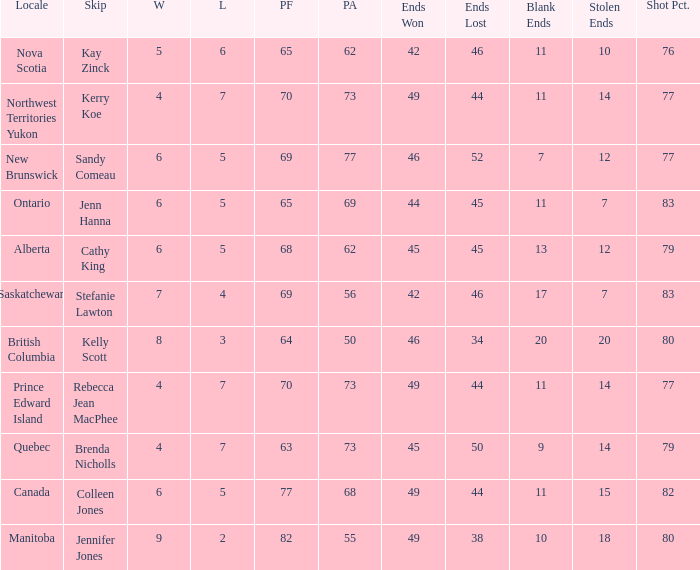Help me parse the entirety of this table. {'header': ['Locale', 'Skip', 'W', 'L', 'PF', 'PA', 'Ends Won', 'Ends Lost', 'Blank Ends', 'Stolen Ends', 'Shot Pct.'], 'rows': [['Nova Scotia', 'Kay Zinck', '5', '6', '65', '62', '42', '46', '11', '10', '76'], ['Northwest Territories Yukon', 'Kerry Koe', '4', '7', '70', '73', '49', '44', '11', '14', '77'], ['New Brunswick', 'Sandy Comeau', '6', '5', '69', '77', '46', '52', '7', '12', '77'], ['Ontario', 'Jenn Hanna', '6', '5', '65', '69', '44', '45', '11', '7', '83'], ['Alberta', 'Cathy King', '6', '5', '68', '62', '45', '45', '13', '12', '79'], ['Saskatchewan', 'Stefanie Lawton', '7', '4', '69', '56', '42', '46', '17', '7', '83'], ['British Columbia', 'Kelly Scott', '8', '3', '64', '50', '46', '34', '20', '20', '80'], ['Prince Edward Island', 'Rebecca Jean MacPhee', '4', '7', '70', '73', '49', '44', '11', '14', '77'], ['Quebec', 'Brenda Nicholls', '4', '7', '63', '73', '45', '50', '9', '14', '79'], ['Canada', 'Colleen Jones', '6', '5', '77', '68', '49', '44', '11', '15', '82'], ['Manitoba', 'Jennifer Jones', '9', '2', '82', '55', '49', '38', '10', '18', '80']]} What is the lowest PF? 63.0. 